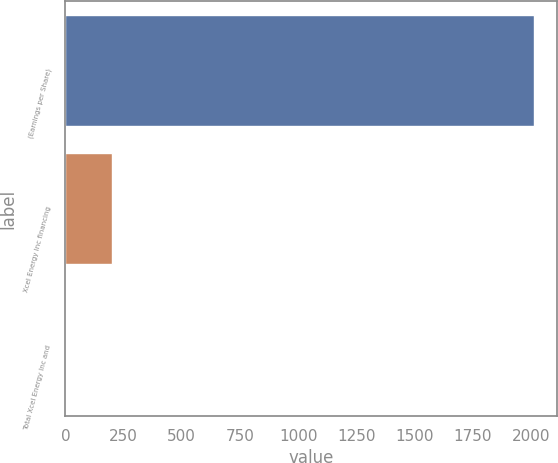Convert chart to OTSL. <chart><loc_0><loc_0><loc_500><loc_500><bar_chart><fcel>(Earnings per Share)<fcel>Xcel Energy Inc financing<fcel>Total Xcel Energy Inc and<nl><fcel>2012<fcel>201.33<fcel>0.14<nl></chart> 